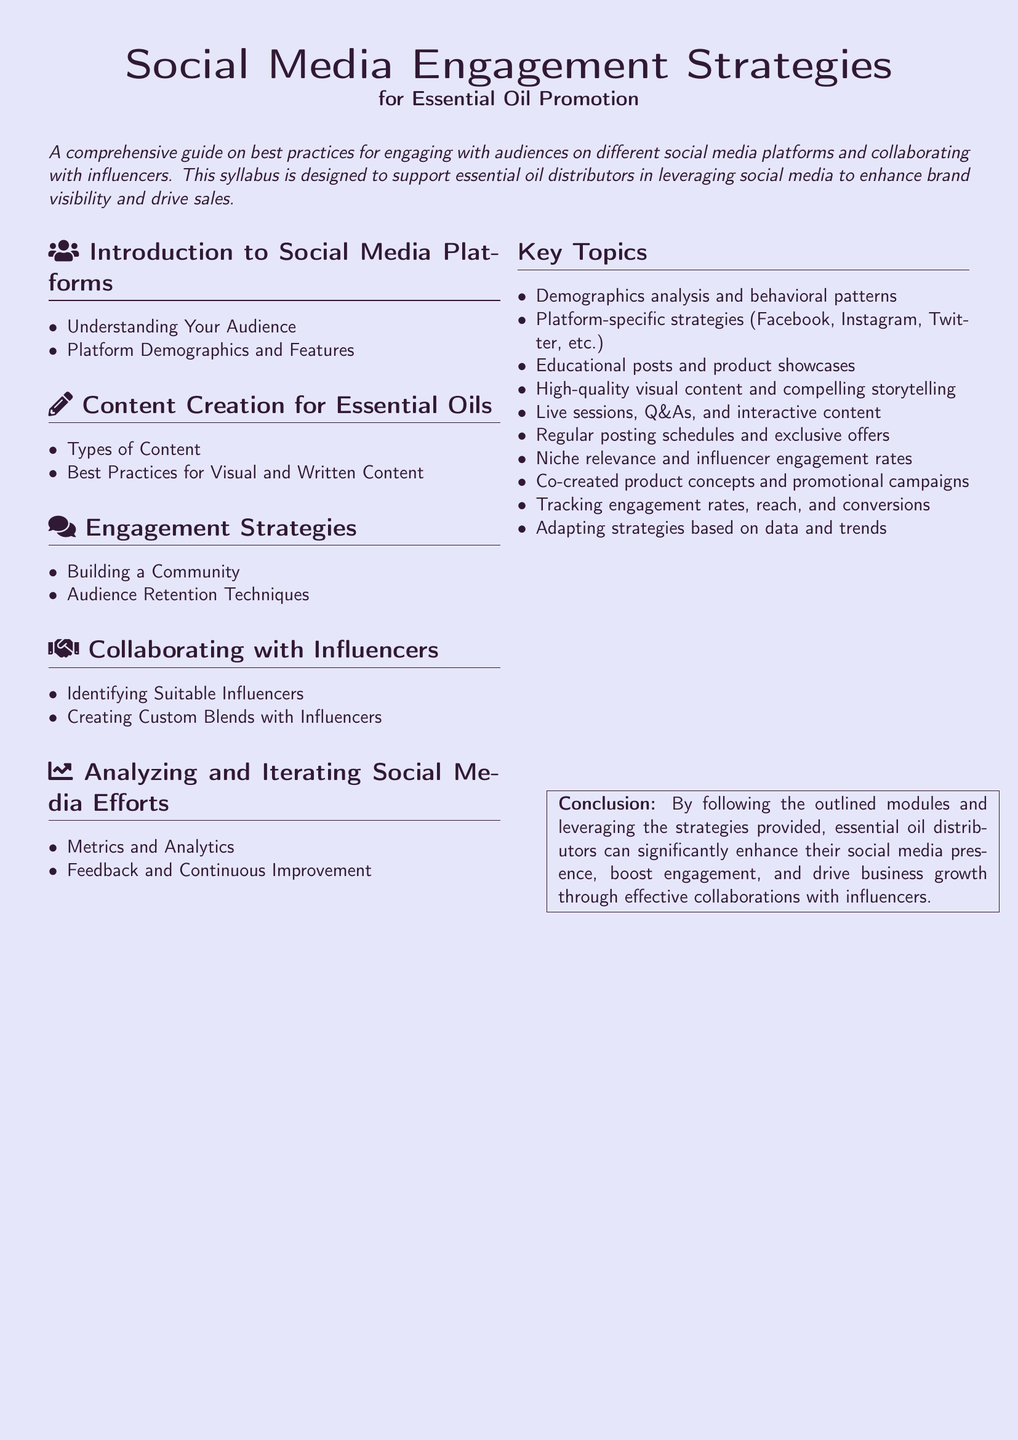What are the main sections of the syllabus? The sections include Introduction to Social Media Platforms, Content Creation for Essential Oils, Engagement Strategies, Collaborating with Influencers, and Analyzing and Iterating Social Media Efforts.
Answer: Introduction to Social Media Platforms, Content Creation for Essential Oils, Engagement Strategies, Collaborating with Influencers, Analyzing and Iterating Social Media Efforts What is the focus of the syllabus? The syllabus outlines best practices for engaging with audiences on social media and collaborating with influencers, designed for essential oil distributors.
Answer: Engaging with audiences on social media and collaborating with influencers How many key topics are listed in the syllabus? The number of key topics is explicitly stated in the document.
Answer: Ten What is one type of content discussed in the content creation section? The document refers to types of content but doesn't specify a particular type in this question.
Answer: Types of Content What technique is mentioned under audience retention? The engagement strategies section lists audience retention techniques, providing guidance on maintaining audience interest.
Answer: Audience Retention Techniques How can essential oil distributors benefit from this syllabus? The conclusion outlines specific advantages regarding social media presence and engagement for essential oil distributors.
Answer: Enhance social media presence, boost engagement, and drive business growth Which platforms are mentioned for platform-specific strategies? The syllabus identifies different platforms in the key topics section related to social media.
Answer: Facebook, Instagram, Twitter, etc What type of influencers should be identified according to the syllabus? The collaboration section specifies the type of influencers that are suitable for essential oil promotion.
Answer: Suitable Influencers 